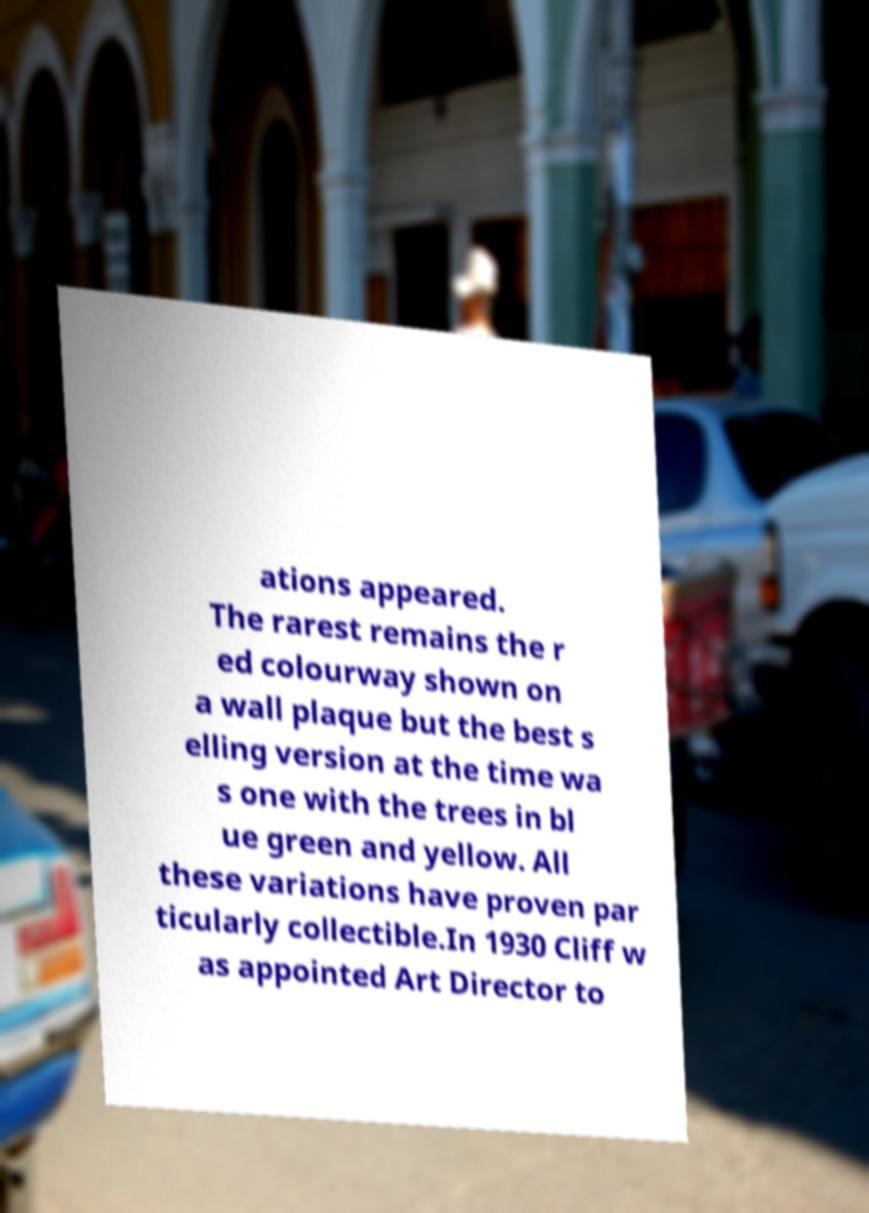For documentation purposes, I need the text within this image transcribed. Could you provide that? ations appeared. The rarest remains the r ed colourway shown on a wall plaque but the best s elling version at the time wa s one with the trees in bl ue green and yellow. All these variations have proven par ticularly collectible.In 1930 Cliff w as appointed Art Director to 